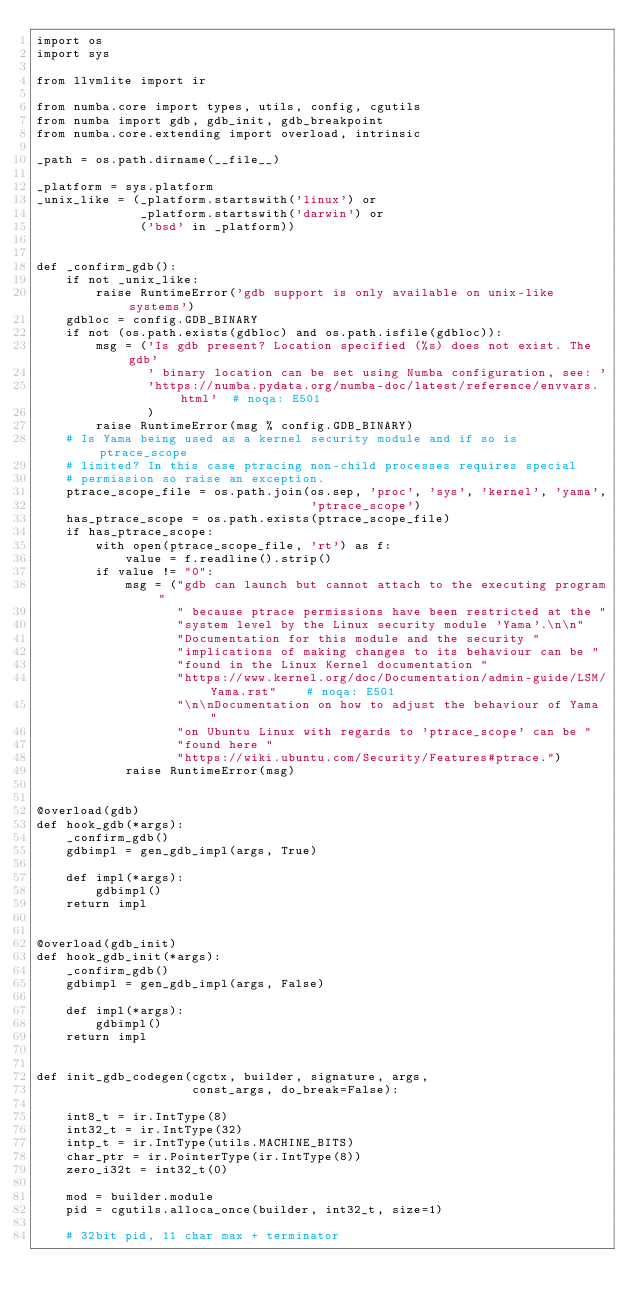Convert code to text. <code><loc_0><loc_0><loc_500><loc_500><_Python_>import os
import sys

from llvmlite import ir

from numba.core import types, utils, config, cgutils
from numba import gdb, gdb_init, gdb_breakpoint
from numba.core.extending import overload, intrinsic

_path = os.path.dirname(__file__)

_platform = sys.platform
_unix_like = (_platform.startswith('linux') or
              _platform.startswith('darwin') or
              ('bsd' in _platform))


def _confirm_gdb():
    if not _unix_like:
        raise RuntimeError('gdb support is only available on unix-like systems')
    gdbloc = config.GDB_BINARY
    if not (os.path.exists(gdbloc) and os.path.isfile(gdbloc)):
        msg = ('Is gdb present? Location specified (%s) does not exist. The gdb'
               ' binary location can be set using Numba configuration, see: '
               'https://numba.pydata.org/numba-doc/latest/reference/envvars.html'  # noqa: E501
               )
        raise RuntimeError(msg % config.GDB_BINARY)
    # Is Yama being used as a kernel security module and if so is ptrace_scope
    # limited? In this case ptracing non-child processes requires special
    # permission so raise an exception.
    ptrace_scope_file = os.path.join(os.sep, 'proc', 'sys', 'kernel', 'yama',
                                     'ptrace_scope')
    has_ptrace_scope = os.path.exists(ptrace_scope_file)
    if has_ptrace_scope:
        with open(ptrace_scope_file, 'rt') as f:
            value = f.readline().strip()
        if value != "0":
            msg = ("gdb can launch but cannot attach to the executing program"
                   " because ptrace permissions have been restricted at the "
                   "system level by the Linux security module 'Yama'.\n\n"
                   "Documentation for this module and the security "
                   "implications of making changes to its behaviour can be "
                   "found in the Linux Kernel documentation "
                   "https://www.kernel.org/doc/Documentation/admin-guide/LSM/Yama.rst"    # noqa: E501
                   "\n\nDocumentation on how to adjust the behaviour of Yama "
                   "on Ubuntu Linux with regards to 'ptrace_scope' can be "
                   "found here "
                   "https://wiki.ubuntu.com/Security/Features#ptrace.")
            raise RuntimeError(msg)


@overload(gdb)
def hook_gdb(*args):
    _confirm_gdb()
    gdbimpl = gen_gdb_impl(args, True)

    def impl(*args):
        gdbimpl()
    return impl


@overload(gdb_init)
def hook_gdb_init(*args):
    _confirm_gdb()
    gdbimpl = gen_gdb_impl(args, False)

    def impl(*args):
        gdbimpl()
    return impl


def init_gdb_codegen(cgctx, builder, signature, args,
                     const_args, do_break=False):

    int8_t = ir.IntType(8)
    int32_t = ir.IntType(32)
    intp_t = ir.IntType(utils.MACHINE_BITS)
    char_ptr = ir.PointerType(ir.IntType(8))
    zero_i32t = int32_t(0)

    mod = builder.module
    pid = cgutils.alloca_once(builder, int32_t, size=1)

    # 32bit pid, 11 char max + terminator</code> 